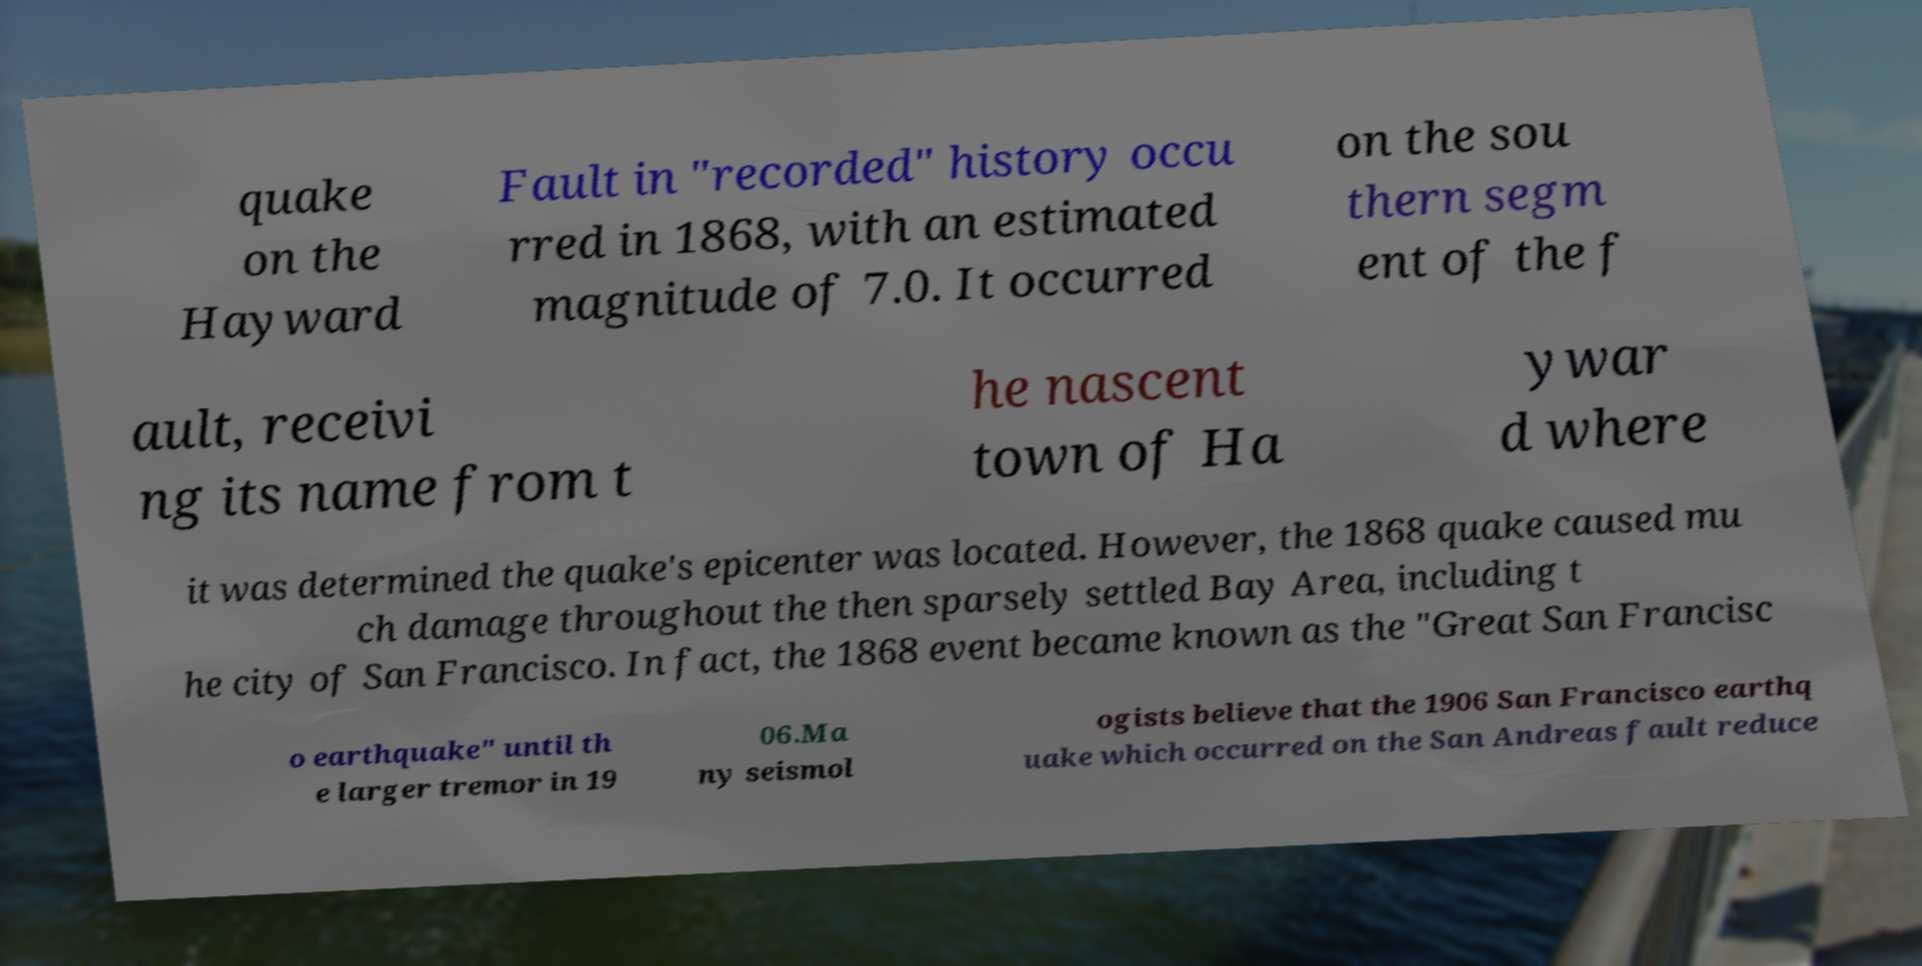Please read and relay the text visible in this image. What does it say? quake on the Hayward Fault in "recorded" history occu rred in 1868, with an estimated magnitude of 7.0. It occurred on the sou thern segm ent of the f ault, receivi ng its name from t he nascent town of Ha ywar d where it was determined the quake's epicenter was located. However, the 1868 quake caused mu ch damage throughout the then sparsely settled Bay Area, including t he city of San Francisco. In fact, the 1868 event became known as the "Great San Francisc o earthquake" until th e larger tremor in 19 06.Ma ny seismol ogists believe that the 1906 San Francisco earthq uake which occurred on the San Andreas fault reduce 